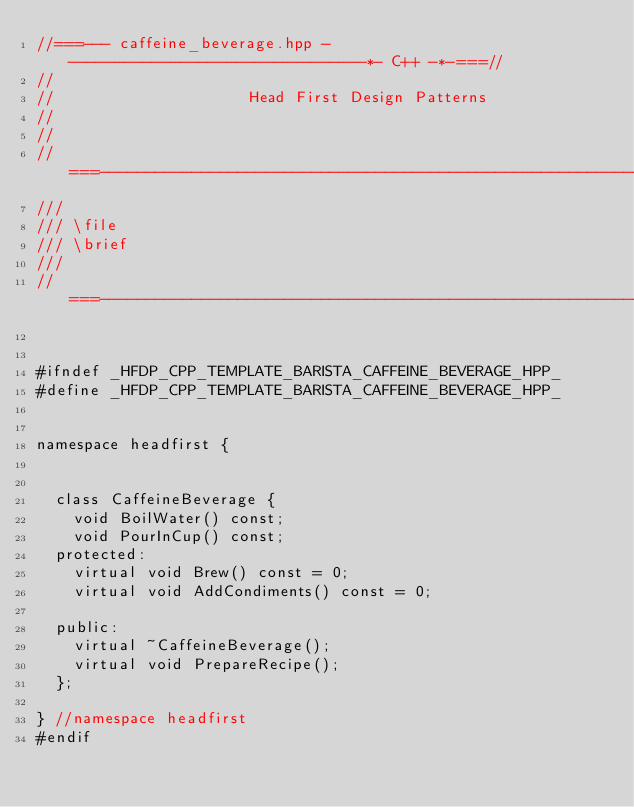<code> <loc_0><loc_0><loc_500><loc_500><_C++_>//===--- caffeine_beverage.hpp - --------------------------------*- C++ -*-===//
//
//                     Head First Design Patterns
//
//
//===----------------------------------------------------------------------===//
///
/// \file
/// \brief
///
//===----------------------------------------------------------------------===//


#ifndef	_HFDP_CPP_TEMPLATE_BARISTA_CAFFEINE_BEVERAGE_HPP_
#define _HFDP_CPP_TEMPLATE_BARISTA_CAFFEINE_BEVERAGE_HPP_


namespace headfirst {


  class CaffeineBeverage {
    void BoilWater() const;
    void PourInCup() const;
  protected:
    virtual void Brew() const = 0;
    virtual void AddCondiments() const = 0;

  public:
    virtual ~CaffeineBeverage();
    virtual void PrepareRecipe();
  };

} //namespace headfirst
#endif
</code> 